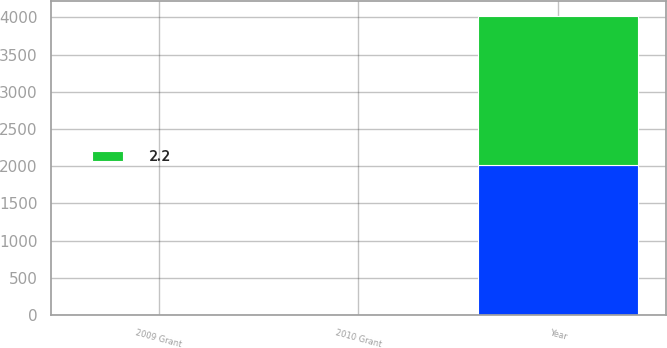Convert chart. <chart><loc_0><loc_0><loc_500><loc_500><stacked_bar_chart><ecel><fcel>Year<fcel>2009 Grant<fcel>2010 Grant<nl><fcel>nan<fcel>2013<fcel>3<fcel>2.3<nl><fcel>2.2<fcel>2012<fcel>1.7<fcel>0.6<nl></chart> 